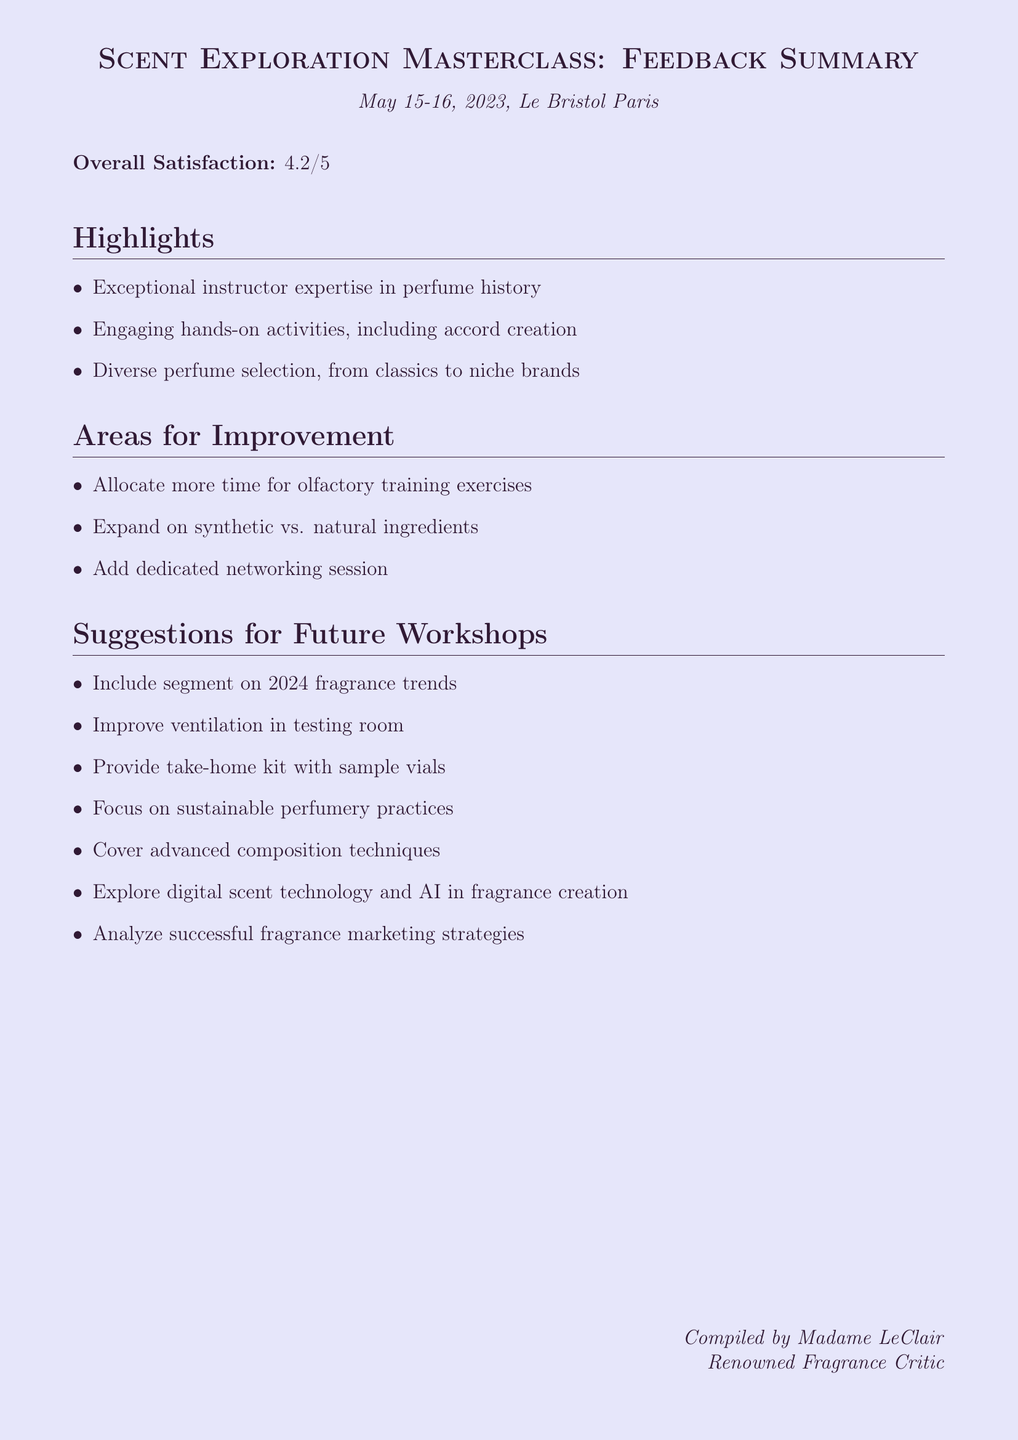What was the overall satisfaction rating? The overall satisfaction rating is directly stated in the document, which is 4.2 out of 5.
Answer: 4.2 How many attendees were there at the workshop? The document mentions that there were a total of 25 attendees present.
Answer: 25 What improvement was suggested regarding time management? The document outlines that attendees suggested more time be allocated for olfactory training exercises specifically.
Answer: Allocate more time for olfactory training exercises Who was the instructor of the workshop? The document refers to the instructor as Madame LeClair, who provided exceptional knowledge.
Answer: Madame LeClair What category does the suggestion for a take-home kit fall under? The document categorizes suggestions into content, facilities, and resources, and the take-home kit is listed under resources.
Answer: Resources Which specific attendee expressed a desire for sustainable practices? The document notes that Sophie Lacoste from Elle Magazine commented on wanting to see more focus on sustainable perfumery practices.
Answer: Sophie Lacoste What topic related to digital innovation is proposed for future workshops? The document lists digital scent technology as an exploration topic, including AI in fragrance creation.
Answer: Digital scent technology What was one of the notable positive feedback comments about the workshop? Attendees expressed positive sentiment regarding the engaging hands-on activities, specifically mentioning creating an accord.
Answer: Creating our own accord was a highlight of the workshop 